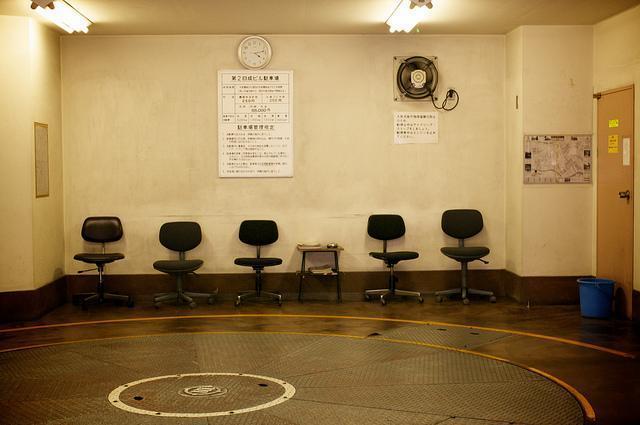How many chairs are there?
Give a very brief answer. 5. How many chairs are in the picture?
Give a very brief answer. 4. 